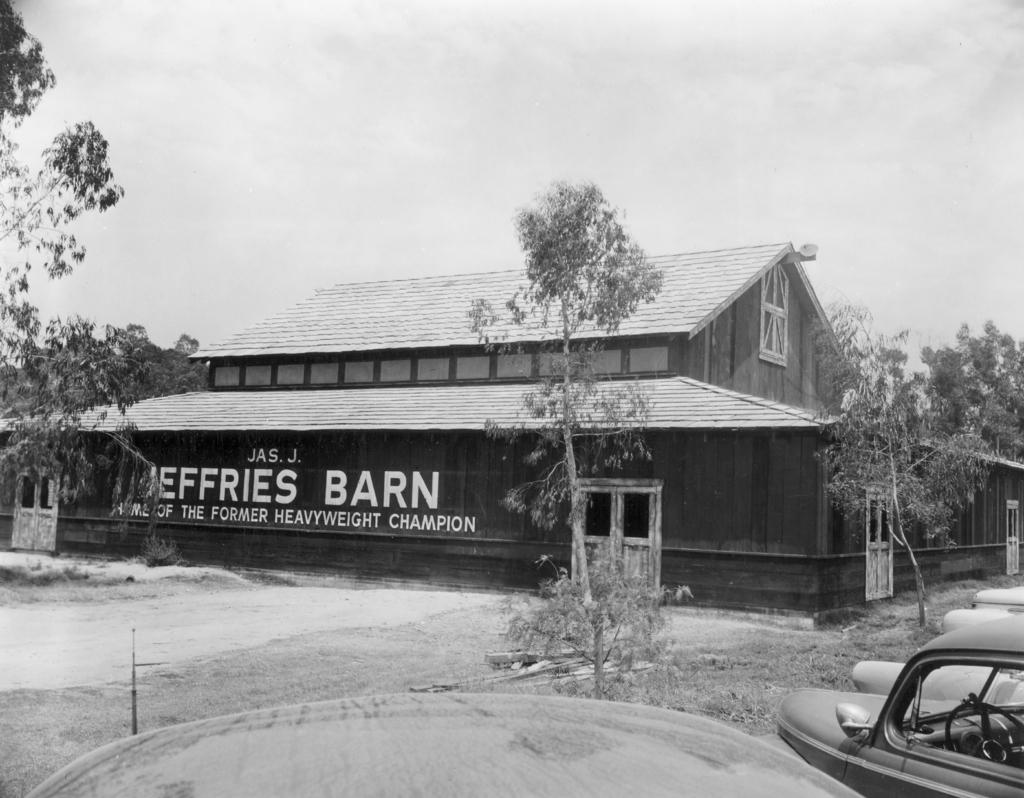What is the color scheme of the image? The image is black and white. What can be seen in the image? There is a vehicle, objects, the ground, trees, grass, a house, and the sky visible in the image. Can you describe the setting of the image? The image features a vehicle, trees, grass, and a house, with the sky visible in the background. What type of pie is being served to the fowl in the image? There is no pie or fowl present in the image; it features a vehicle, trees, grass, and a house, with the sky visible in the background. 